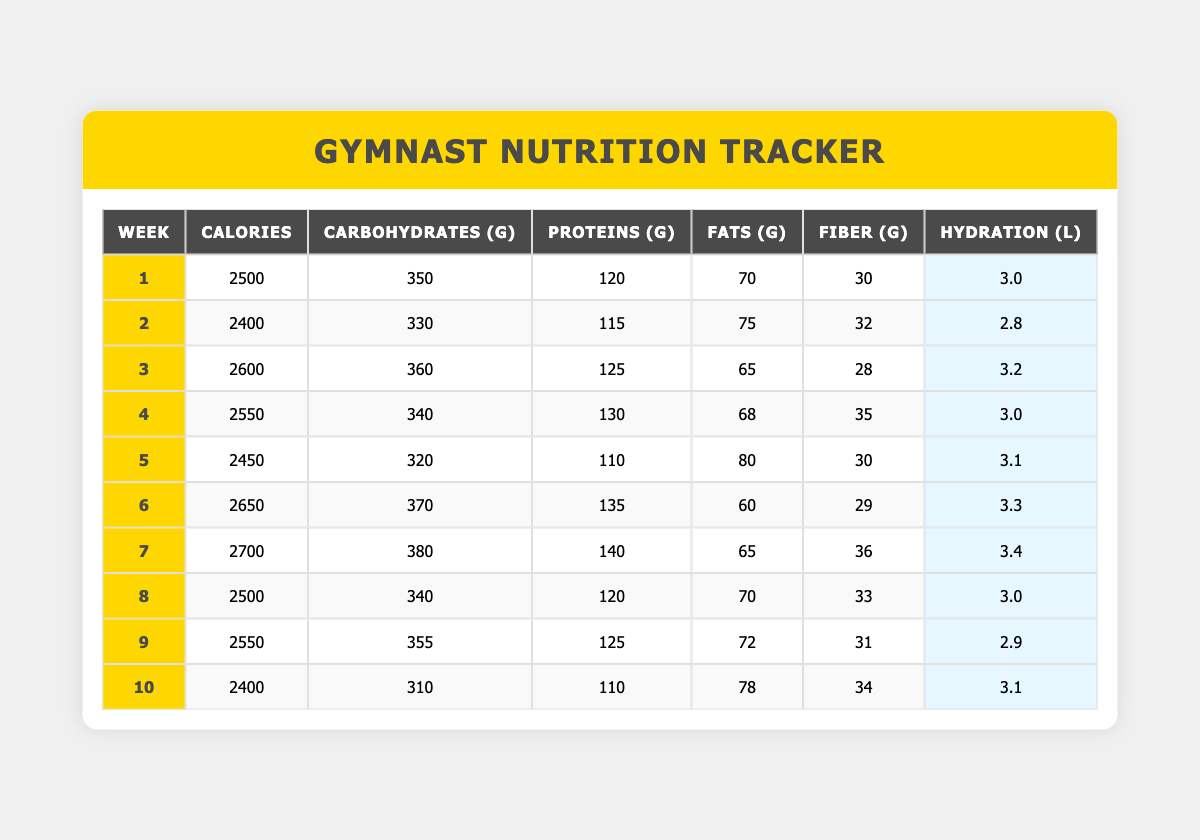What was the calorie intake during week 5? The table shows the Calories for week 5, which is listed as 2450.
Answer: 2450 Which week had the highest protein intake? By reviewing the table, week 7 has the highest protein intake at 140 grams.
Answer: Week 7 What is the average carbohydrate intake over the 10 weeks? The total carbohydrate intake for all weeks is 3,560 grams (350 + 330 + 360 + 340 + 320 + 370 + 380 + 340 + 355 + 310) which divided by 10 weeks gives an average of 356.
Answer: 356 grams Did the hydration increase from week 2 to week 3? Week 2 has 2.8 liters of hydration and week 3 has 3.2 liters, indicating an increase.
Answer: Yes How much more fiber was consumed in week 4 compared to week 9? Week 4 had 35 grams of fiber, and week 9 had 31 grams. The difference is 35 - 31 = 4 grams more in week 4.
Answer: 4 grams What was the total fat intake across all weeks? The total fat intake sums up to 65 + 75 + 68 + 80 + 60 + 65 + 70 + 72 + 78 = 600 grams.
Answer: 600 grams Which week had both the highest caloric and carbohydrate intake? Week 7 had the highest calories (2700) and the highest carbohydrates (380), meeting both criteria.
Answer: Week 7 Was there a decrease in protein intake from week 6 to week 10? Week 6 had 135 grams of protein while week 10 had 110 grams; this is a decrease of 25 grams.
Answer: Yes What is the change in hydration from week 1 to week 7? Week 1 had 3.0 liters and week 7 had 3.4 liters; the change is 3.4 - 3.0 = 0.4 liters increase.
Answer: 0.4 liters increase What was the average calorie intake for the first half of the training season? The average for weeks 1 to 5 is (2500 + 2400 + 2600 + 2550 + 2450) / 5 = 2510 calories.
Answer: 2510 calories 